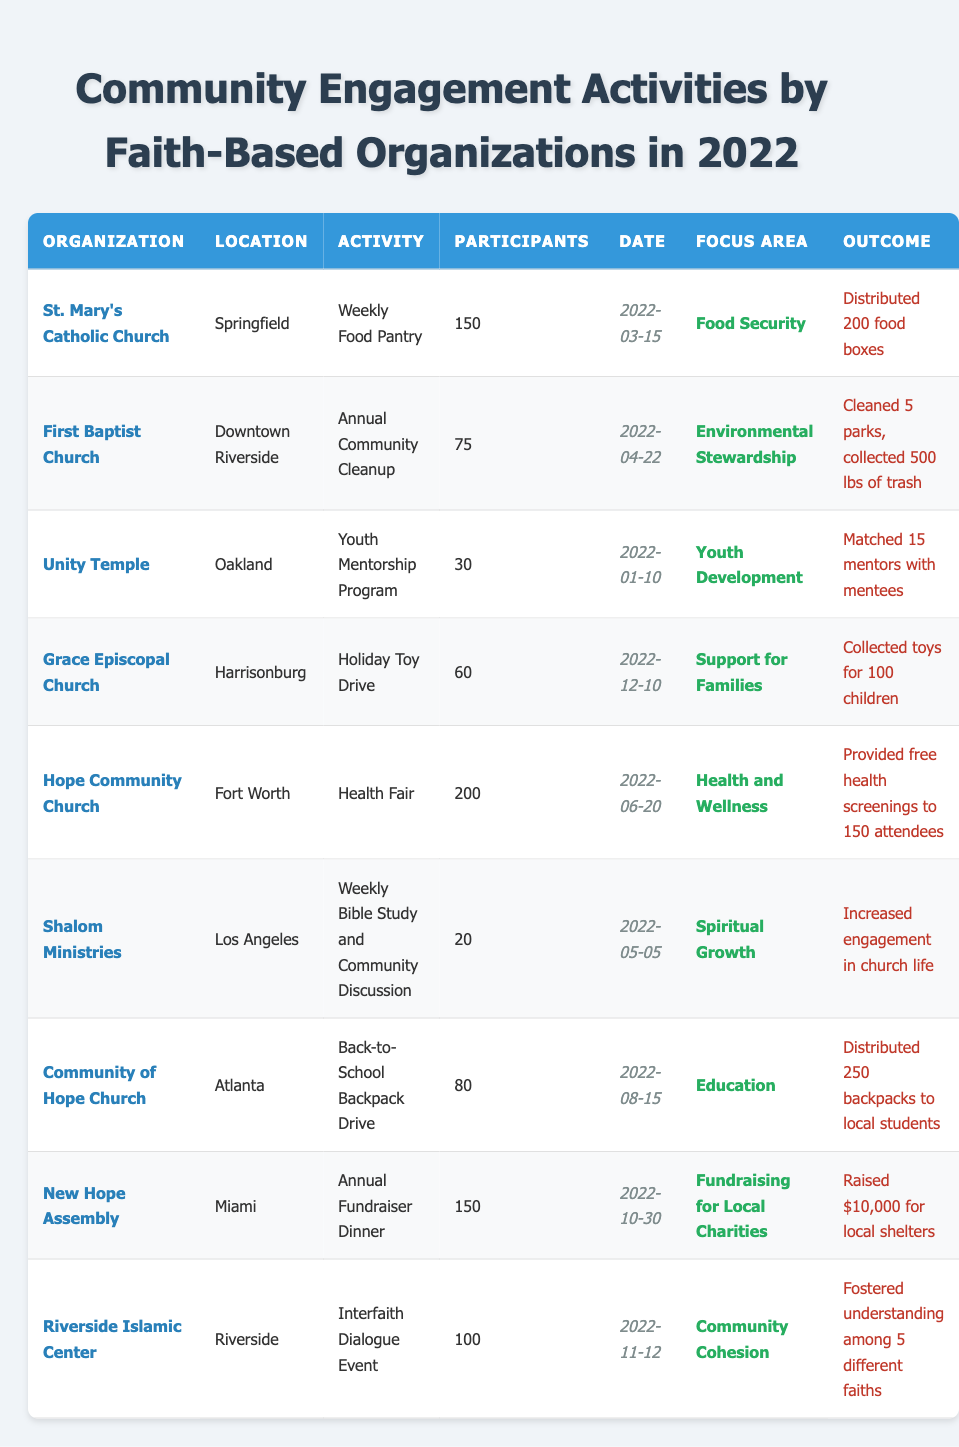What organization hosted the Health Fair? By reviewing the table, I located the activity "Health Fair," which is associated with Hope Community Church in Fort Worth.
Answer: Hope Community Church What was the total number of participants in the activities focused on youth development? The only activity focused on youth development was the Youth Mentorship Program at Unity Temple with 30 participants. Therefore, the total number of participants is just 30.
Answer: 30 Did St. Mary's Catholic Church distribute food boxes during their engagement activity? Yes, St. Mary's Catholic Church was involved in the Weekly Food Pantry and the outcome specified that they distributed 200 food boxes.
Answer: Yes Which organization organized a fundraiser dinner, and how much money did they raise? The Annual Fundraiser Dinner was organized by New Hope Assembly, and according to the outcome section, they raised $10,000 for local shelters.
Answer: New Hope Assembly, $10,000 How many community engagement activities took place in the city of Riverside? There are two organizations listed in the table located in Riverside: First Baptist Church and Riverside Islamic Center, each hosting one community engagement activity. Thus, the total is 2.
Answer: 2 What is the difference in the number of participants between the Health Fair and the Weekly Bible Study? The Health Fair had 200 participants and the Weekly Bible Study had 20 participants. The difference is calculated as 200 - 20 = 180 participants.
Answer: 180 What focus area had the highest number of participants, and how many participated in that area? The Health and Wellness focus area hosted the Health Fair with the highest number of participants at 200. Thus, the answer is Health and Wellness with 200 participants.
Answer: Health and Wellness, 200 Which activity involved interfaith dialogue, and how many participants were there? The Interfaith Dialogue Event was organized by Riverside Islamic Center, and it had 100 participants according to the activity details.
Answer: Interfaith Dialogue Event, 100 participants How many total backpacks were distributed in the back-to-school drive? The back-to-school drive, organized by Community of Hope Church, distributed a total of 250 backpacks to local students as per the outcome section.
Answer: 250 Was there more participation in food security activities or in environmental stewardship activities? The Weekly Food Pantry (150 participants) and the Annual Community Cleanup (75 participants) involve food security and environmental stewardship respectively. 150 (food security) > 75 (environmental stewardship).
Answer: Food security had more participants 